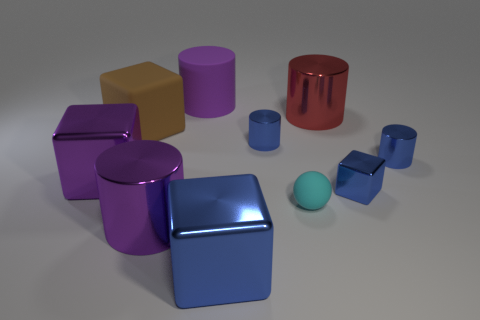Subtract 1 cylinders. How many cylinders are left? 4 Subtract all red cylinders. How many cylinders are left? 4 Subtract all brown cubes. How many cubes are left? 3 Subtract all green cylinders. Subtract all cyan blocks. How many cylinders are left? 5 Subtract all blocks. How many objects are left? 6 Add 3 rubber cylinders. How many rubber cylinders exist? 4 Subtract 0 green cylinders. How many objects are left? 10 Subtract all cyan balls. Subtract all cyan matte balls. How many objects are left? 8 Add 3 tiny blue shiny blocks. How many tiny blue shiny blocks are left? 4 